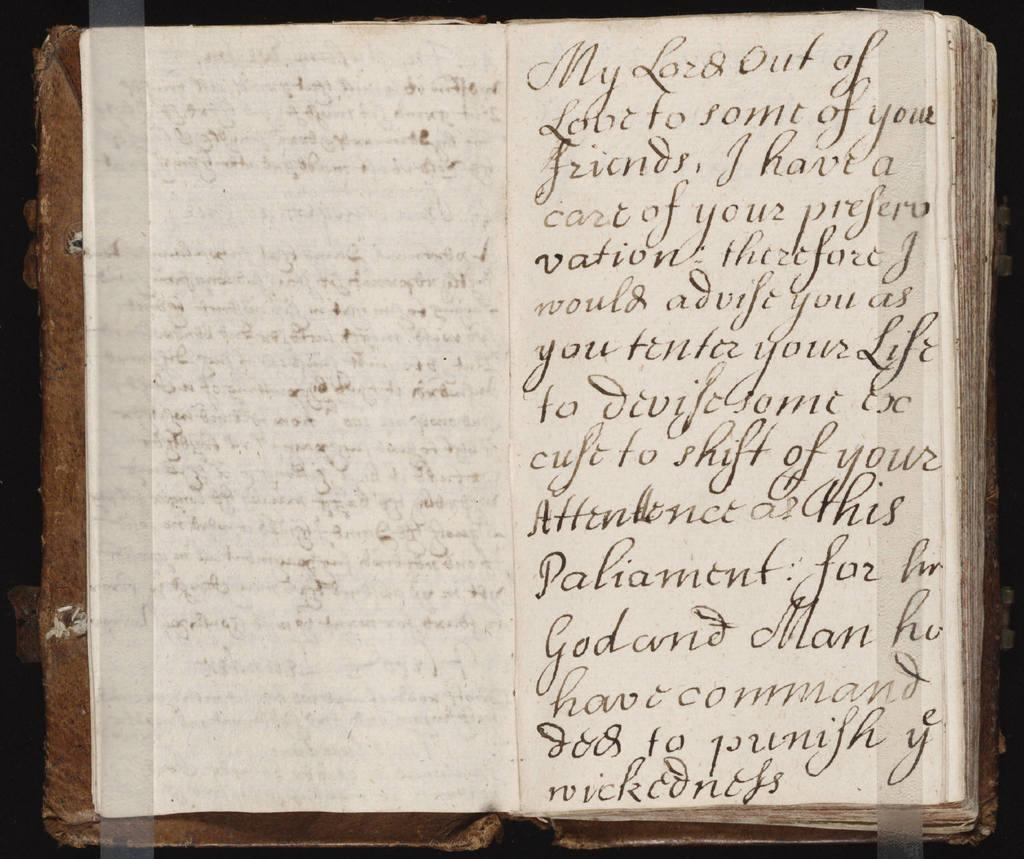<image>
Summarize the visual content of the image. the word command is on the page in a book 